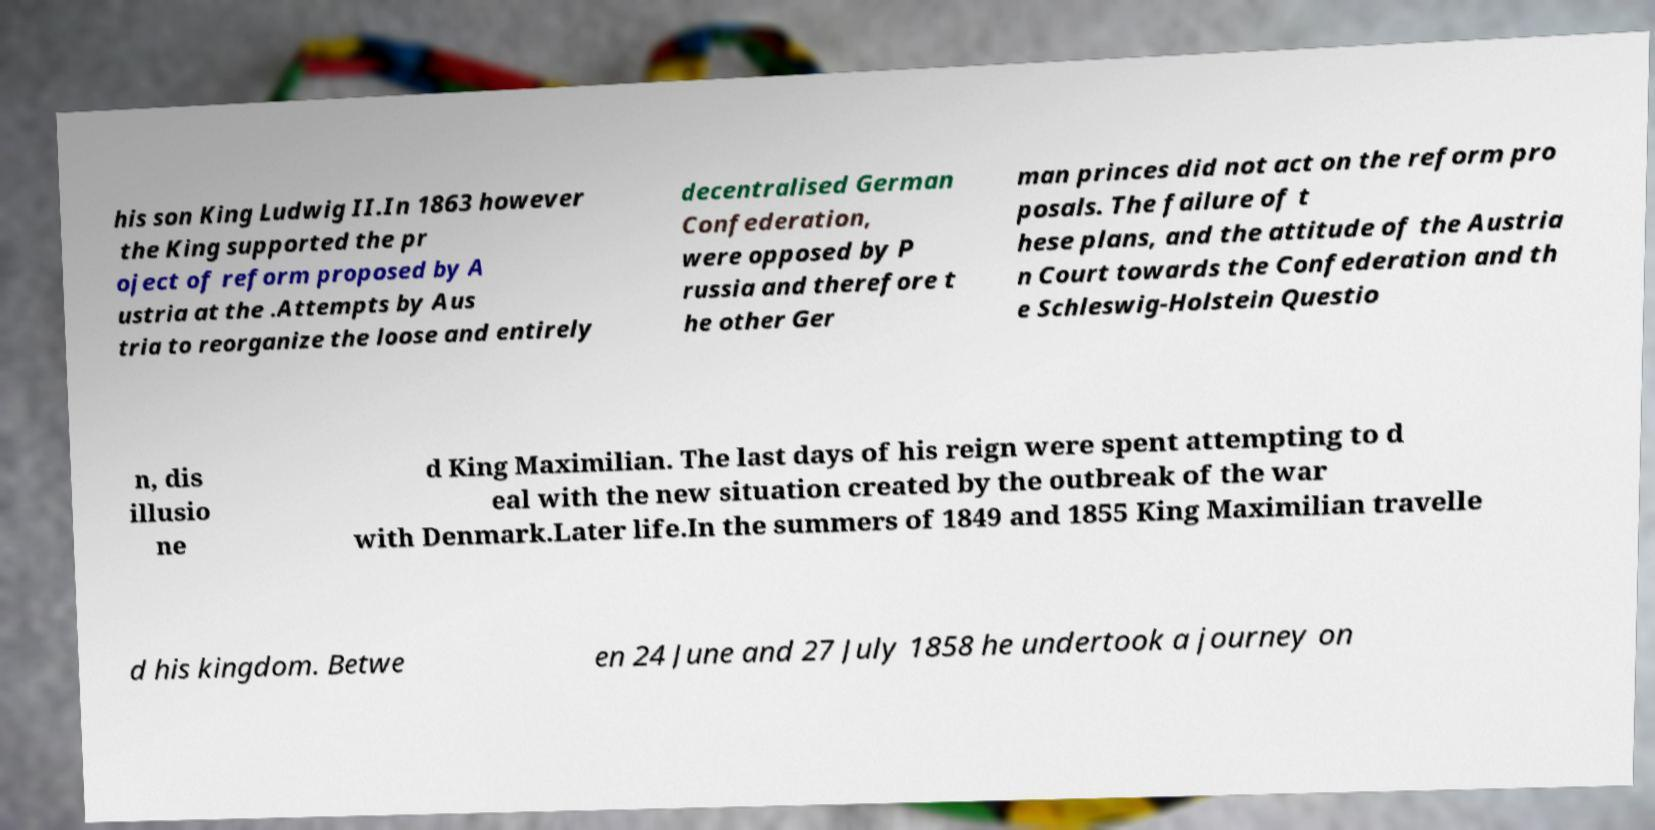I need the written content from this picture converted into text. Can you do that? his son King Ludwig II.In 1863 however the King supported the pr oject of reform proposed by A ustria at the .Attempts by Aus tria to reorganize the loose and entirely decentralised German Confederation, were opposed by P russia and therefore t he other Ger man princes did not act on the reform pro posals. The failure of t hese plans, and the attitude of the Austria n Court towards the Confederation and th e Schleswig-Holstein Questio n, dis illusio ne d King Maximilian. The last days of his reign were spent attempting to d eal with the new situation created by the outbreak of the war with Denmark.Later life.In the summers of 1849 and 1855 King Maximilian travelle d his kingdom. Betwe en 24 June and 27 July 1858 he undertook a journey on 